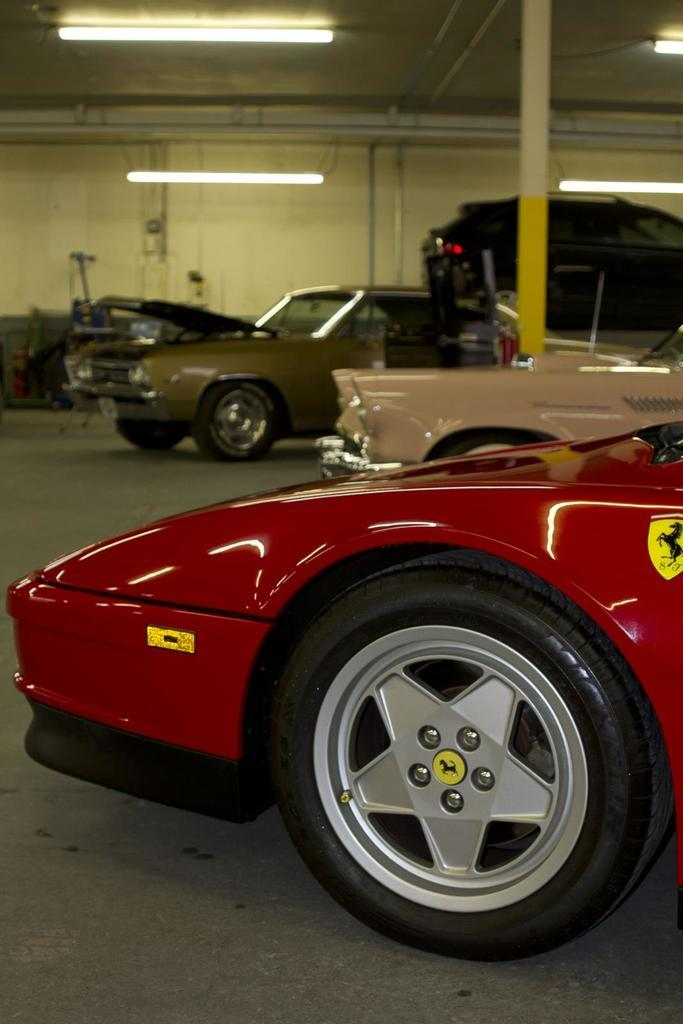What type of vehicles can be seen in the image? There are cars in the image. What colors are the cars? The cars are in red, cream, and brown colors. What is the purpose of the pole in the image? The purpose of the pole is not specified, but it could be for supporting lights or other fixtures. What type of illumination is present in the image? There are lights in the image. What type of structure is visible in the image? There is a wall in the image. How many brothers are standing next to the cars in the image? There is no mention of brothers in the image, so we cannot answer this question. 